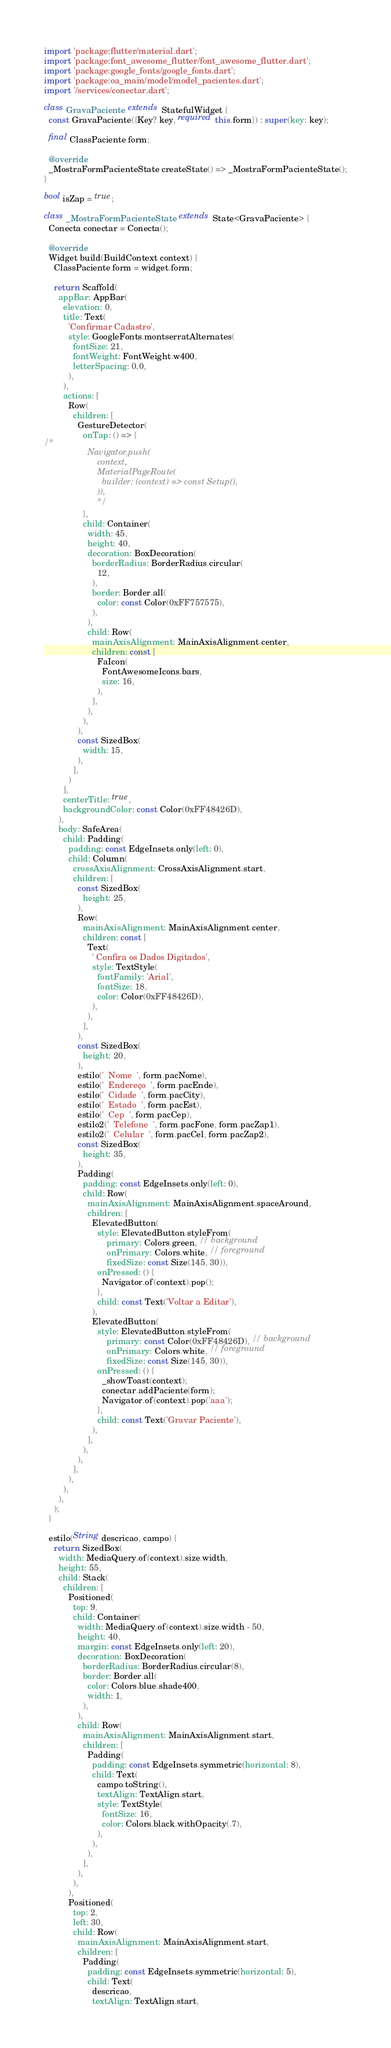Convert code to text. <code><loc_0><loc_0><loc_500><loc_500><_Dart_>import 'package:flutter/material.dart';
import 'package:font_awesome_flutter/font_awesome_flutter.dart';
import 'package:google_fonts/google_fonts.dart';
import 'package:oa_main/model/model_pacientes.dart';
import '/services/conectar.dart';

class GravaPaciente extends StatefulWidget {
  const GravaPaciente({Key? key, required this.form}) : super(key: key);

  final ClassPaciente form;

  @override
  _MostraFormPacienteState createState() => _MostraFormPacienteState();
}

bool isZap = true;

class _MostraFormPacienteState extends State<GravaPaciente> {
  Conecta conectar = Conecta();

  @override
  Widget build(BuildContext context) {
    ClassPaciente form = widget.form;

    return Scaffold(
      appBar: AppBar(
        elevation: 0,
        title: Text(
          'Confirmar Cadastro',
          style: GoogleFonts.montserratAlternates(
            fontSize: 21,
            fontWeight: FontWeight.w400,
            letterSpacing: 0.0,
          ),
        ),
        actions: [
          Row(
            children: [
              GestureDetector(
                onTap: () => {
/*
                  Navigator.push(
                      context,
                      MaterialPageRoute(
                        builder: (context) => const Setup(),
                      )),
                      */
                },
                child: Container(
                  width: 45,
                  height: 40,
                  decoration: BoxDecoration(
                    borderRadius: BorderRadius.circular(
                      12,
                    ),
                    border: Border.all(
                      color: const Color(0xFF757575),
                    ),
                  ),
                  child: Row(
                    mainAxisAlignment: MainAxisAlignment.center,
                    children: const [
                      FaIcon(
                        FontAwesomeIcons.bars,
                        size: 16,
                      ),
                    ],
                  ),
                ),
              ),
              const SizedBox(
                width: 15,
              ),
            ],
          )
        ],
        centerTitle: true,
        backgroundColor: const Color(0xFF48426D),
      ),
      body: SafeArea(
        child: Padding(
          padding: const EdgeInsets.only(left: 0),
          child: Column(
            crossAxisAlignment: CrossAxisAlignment.start,
            children: [
              const SizedBox(
                height: 25,
              ),
              Row(
                mainAxisAlignment: MainAxisAlignment.center,
                children: const [
                  Text(
                    ' Confira os Dados Digitados',
                    style: TextStyle(
                      fontFamily: 'Arial',
                      fontSize: 18,
                      color: Color(0xFF48426D),
                    ),
                  ),
                ],
              ),
              const SizedBox(
                height: 20,
              ),
              estilo('  Nome  ', form.pacNome),
              estilo('  Endereço  ', form.pacEnde),
              estilo('  Cidade  ', form.pacCity),
              estilo('  Estado  ', form.pacEst),
              estilo('  Cep  ', form.pacCep),
              estilo2('  Telefone  ', form.pacFone, form.pacZap1),
              estilo2('  Celular  ', form.pacCel, form.pacZap2),
              const SizedBox(
                height: 35,
              ),
              Padding(
                padding: const EdgeInsets.only(left: 0),
                child: Row(
                  mainAxisAlignment: MainAxisAlignment.spaceAround,
                  children: [
                    ElevatedButton(
                      style: ElevatedButton.styleFrom(
                          primary: Colors.green, // background
                          onPrimary: Colors.white, // foreground
                          fixedSize: const Size(145, 30)),
                      onPressed: () {
                        Navigator.of(context).pop();
                      },
                      child: const Text('Voltar a Editar'),
                    ),
                    ElevatedButton(
                      style: ElevatedButton.styleFrom(
                          primary: const Color(0xFF48426D), // background
                          onPrimary: Colors.white, // foreground
                          fixedSize: const Size(145, 30)),
                      onPressed: () {
                        _showToast(context);
                        conectar.addPaciente(form);
                        Navigator.of(context).pop('aaa');
                      },
                      child: const Text('Gravar Paciente'),
                    ),
                  ],
                ),
              ),
            ],
          ),
        ),
      ),
    );
  }

  estilo(String descricao, campo) {
    return SizedBox(
      width: MediaQuery.of(context).size.width,
      height: 55,
      child: Stack(
        children: [
          Positioned(
            top: 9,
            child: Container(
              width: MediaQuery.of(context).size.width - 50,
              height: 40,
              margin: const EdgeInsets.only(left: 20),
              decoration: BoxDecoration(
                borderRadius: BorderRadius.circular(8),
                border: Border.all(
                  color: Colors.blue.shade400,
                  width: 1,
                ),
              ),
              child: Row(
                mainAxisAlignment: MainAxisAlignment.start,
                children: [
                  Padding(
                    padding: const EdgeInsets.symmetric(horizontal: 8),
                    child: Text(
                      campo.toString(),
                      textAlign: TextAlign.start,
                      style: TextStyle(
                        fontSize: 16,
                        color: Colors.black.withOpacity(.7),
                      ),
                    ),
                  ),
                ],
              ),
            ),
          ),
          Positioned(
            top: 2,
            left: 30,
            child: Row(
              mainAxisAlignment: MainAxisAlignment.start,
              children: [
                Padding(
                  padding: const EdgeInsets.symmetric(horizontal: 5),
                  child: Text(
                    descricao,
                    textAlign: TextAlign.start,</code> 